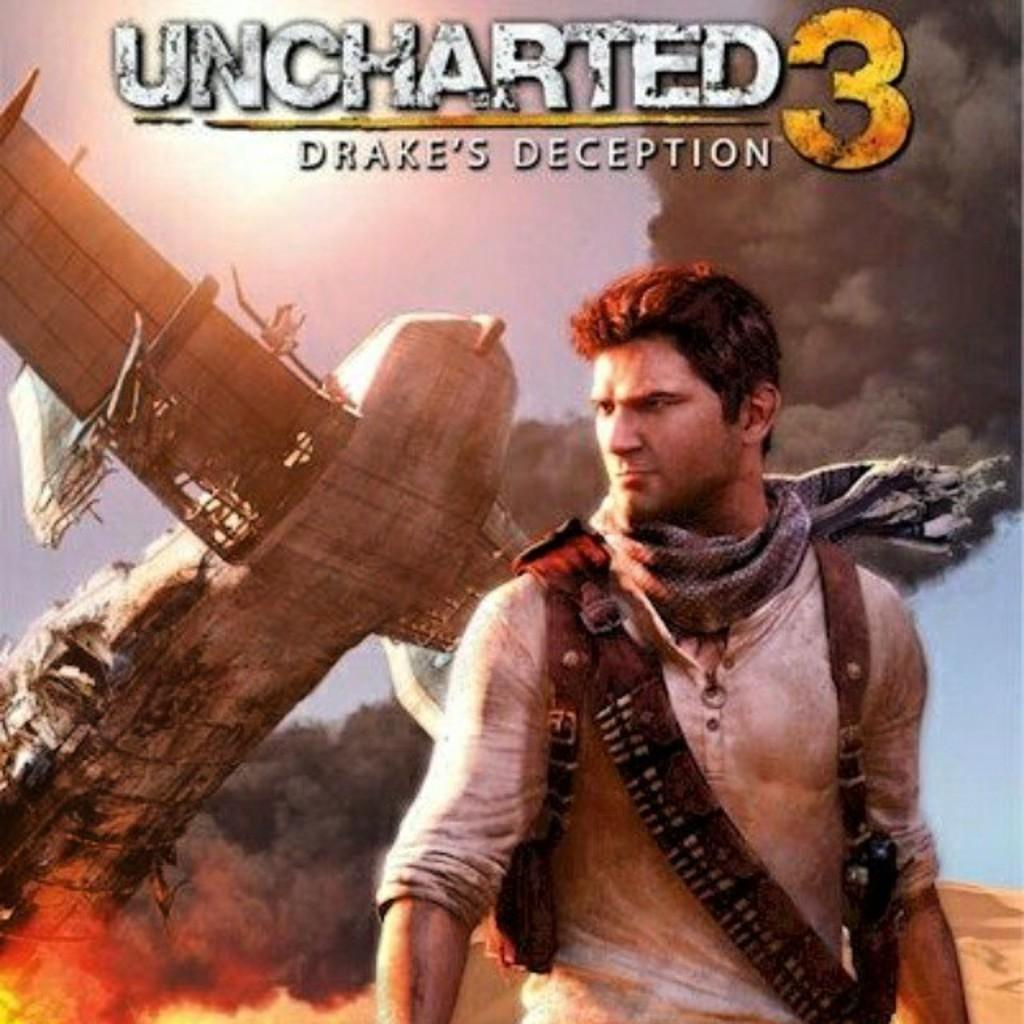<image>
Give a short and clear explanation of the subsequent image. A poster for the videogame Unchartered 3, Drake's Deception, pictures a plance crashing and a man in the foreground. 